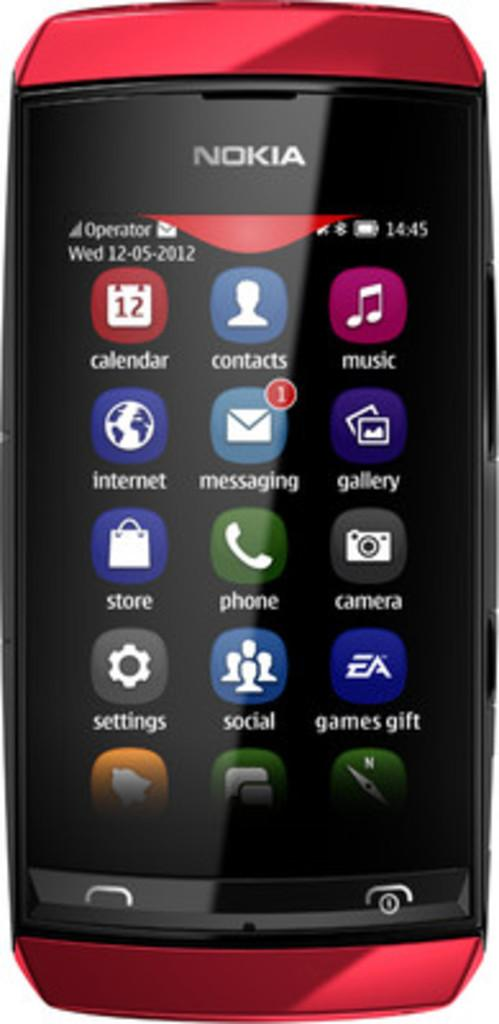Provide a one-sentence caption for the provided image. A red and black cell phone from the brand Nokia has multiple apps on the screen. 